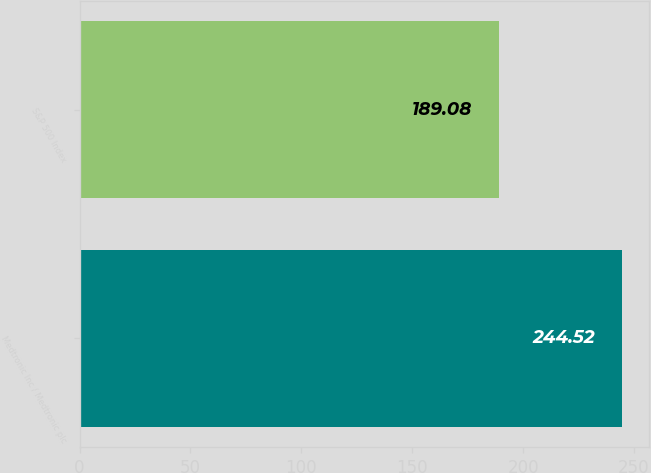Convert chart. <chart><loc_0><loc_0><loc_500><loc_500><bar_chart><fcel>Medtronic Inc / Medtronic plc<fcel>S&P 500 Index<nl><fcel>244.52<fcel>189.08<nl></chart> 